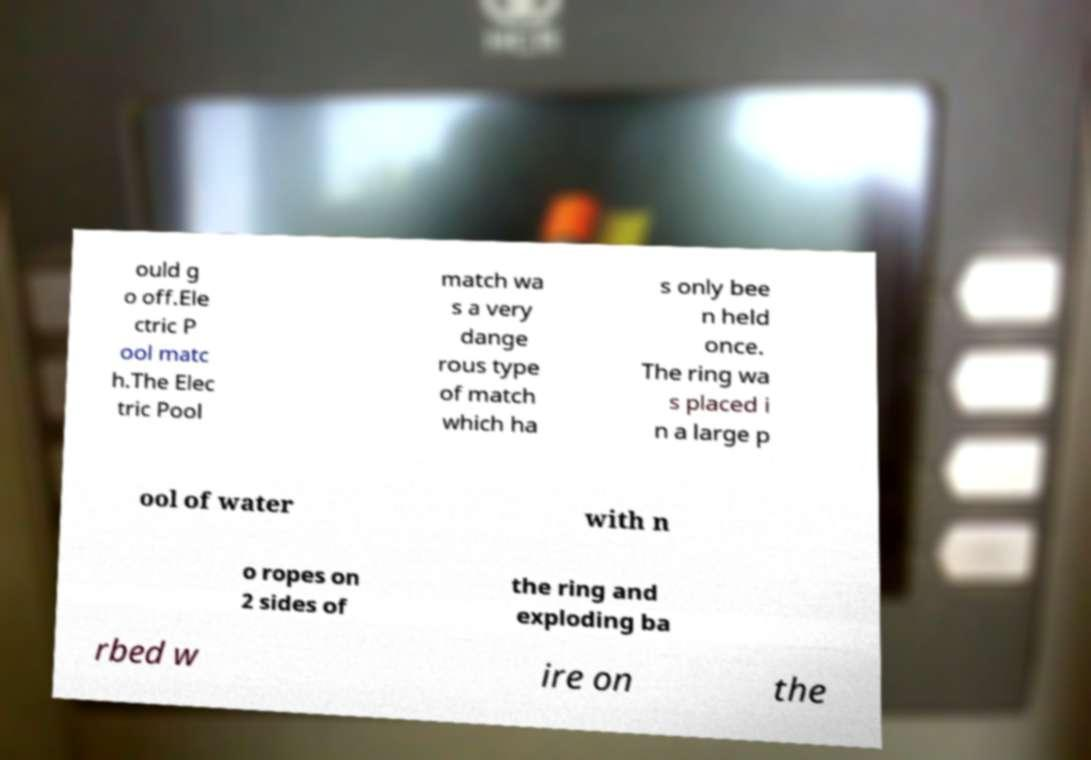Can you accurately transcribe the text from the provided image for me? ould g o off.Ele ctric P ool matc h.The Elec tric Pool match wa s a very dange rous type of match which ha s only bee n held once. The ring wa s placed i n a large p ool of water with n o ropes on 2 sides of the ring and exploding ba rbed w ire on the 